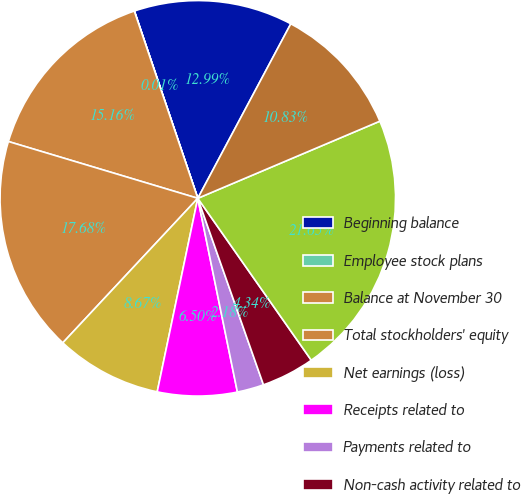<chart> <loc_0><loc_0><loc_500><loc_500><pie_chart><fcel>Beginning balance<fcel>Employee stock plans<fcel>Balance at November 30<fcel>Total stockholders' equity<fcel>Net earnings (loss)<fcel>Receipts related to<fcel>Payments related to<fcel>Non-cash activity related to<fcel>Total equity<fcel>Comprehensive earnings (loss)<nl><fcel>12.99%<fcel>0.01%<fcel>15.16%<fcel>17.68%<fcel>8.67%<fcel>6.5%<fcel>2.18%<fcel>4.34%<fcel>21.65%<fcel>10.83%<nl></chart> 